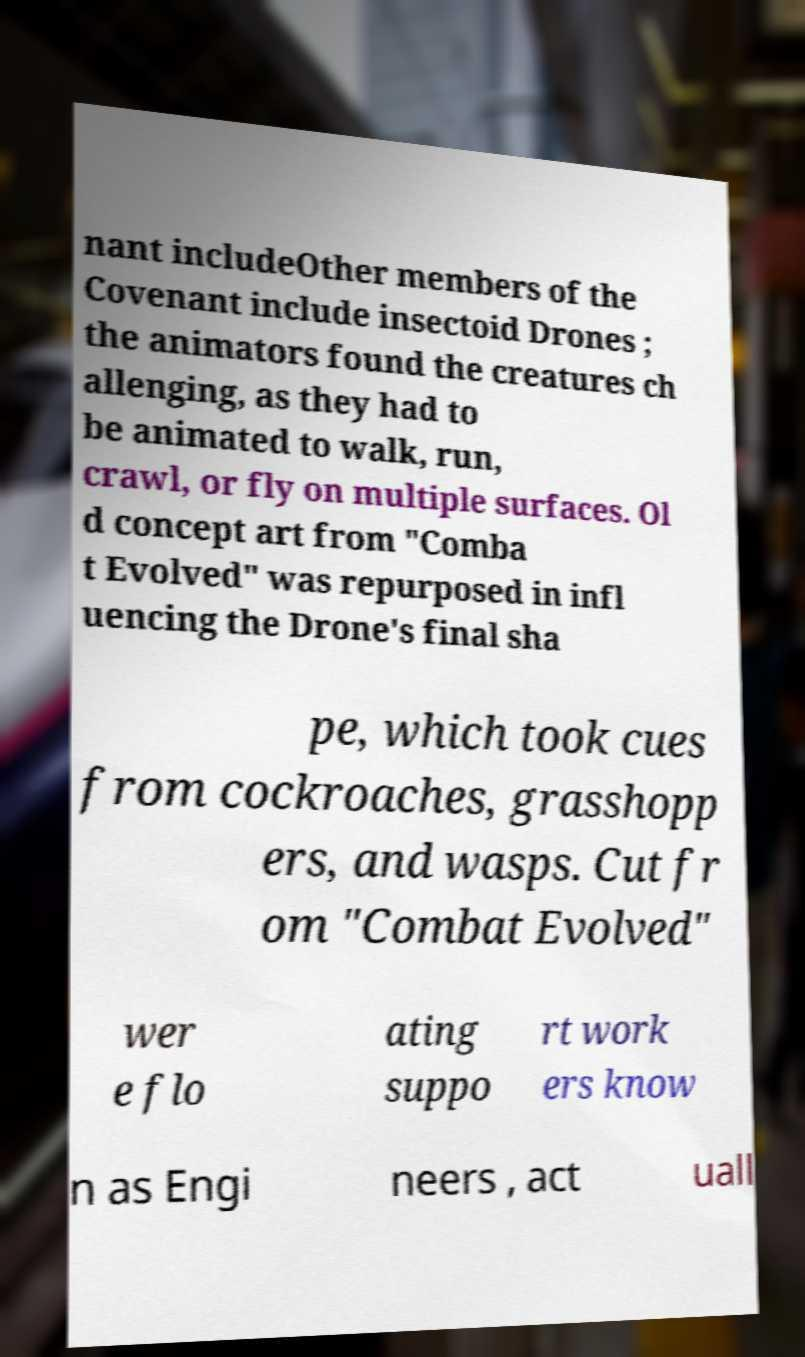Could you extract and type out the text from this image? nant includeOther members of the Covenant include insectoid Drones ; the animators found the creatures ch allenging, as they had to be animated to walk, run, crawl, or fly on multiple surfaces. Ol d concept art from "Comba t Evolved" was repurposed in infl uencing the Drone's final sha pe, which took cues from cockroaches, grasshopp ers, and wasps. Cut fr om "Combat Evolved" wer e flo ating suppo rt work ers know n as Engi neers , act uall 